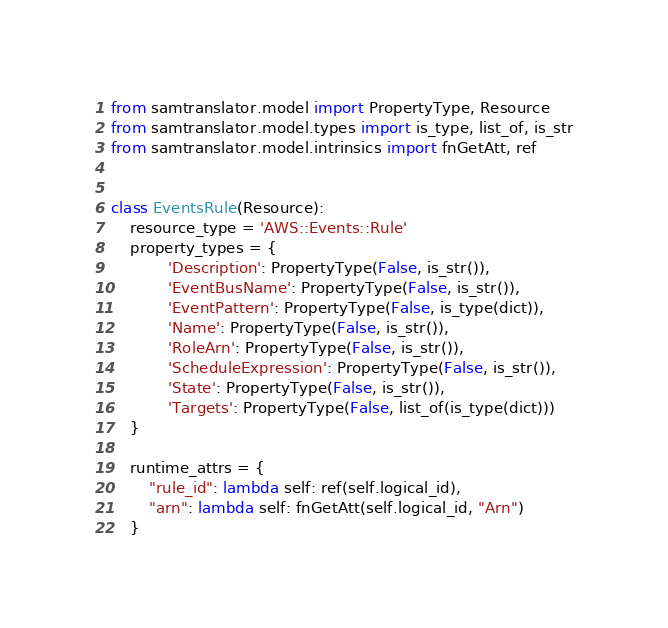Convert code to text. <code><loc_0><loc_0><loc_500><loc_500><_Python_>from samtranslator.model import PropertyType, Resource
from samtranslator.model.types import is_type, list_of, is_str
from samtranslator.model.intrinsics import fnGetAtt, ref


class EventsRule(Resource):
    resource_type = 'AWS::Events::Rule'
    property_types = {
            'Description': PropertyType(False, is_str()),
            'EventBusName': PropertyType(False, is_str()),
            'EventPattern': PropertyType(False, is_type(dict)),
            'Name': PropertyType(False, is_str()),
            'RoleArn': PropertyType(False, is_str()),
            'ScheduleExpression': PropertyType(False, is_str()),
            'State': PropertyType(False, is_str()),
            'Targets': PropertyType(False, list_of(is_type(dict)))
    }

    runtime_attrs = {
        "rule_id": lambda self: ref(self.logical_id),
        "arn": lambda self: fnGetAtt(self.logical_id, "Arn")
    }
</code> 